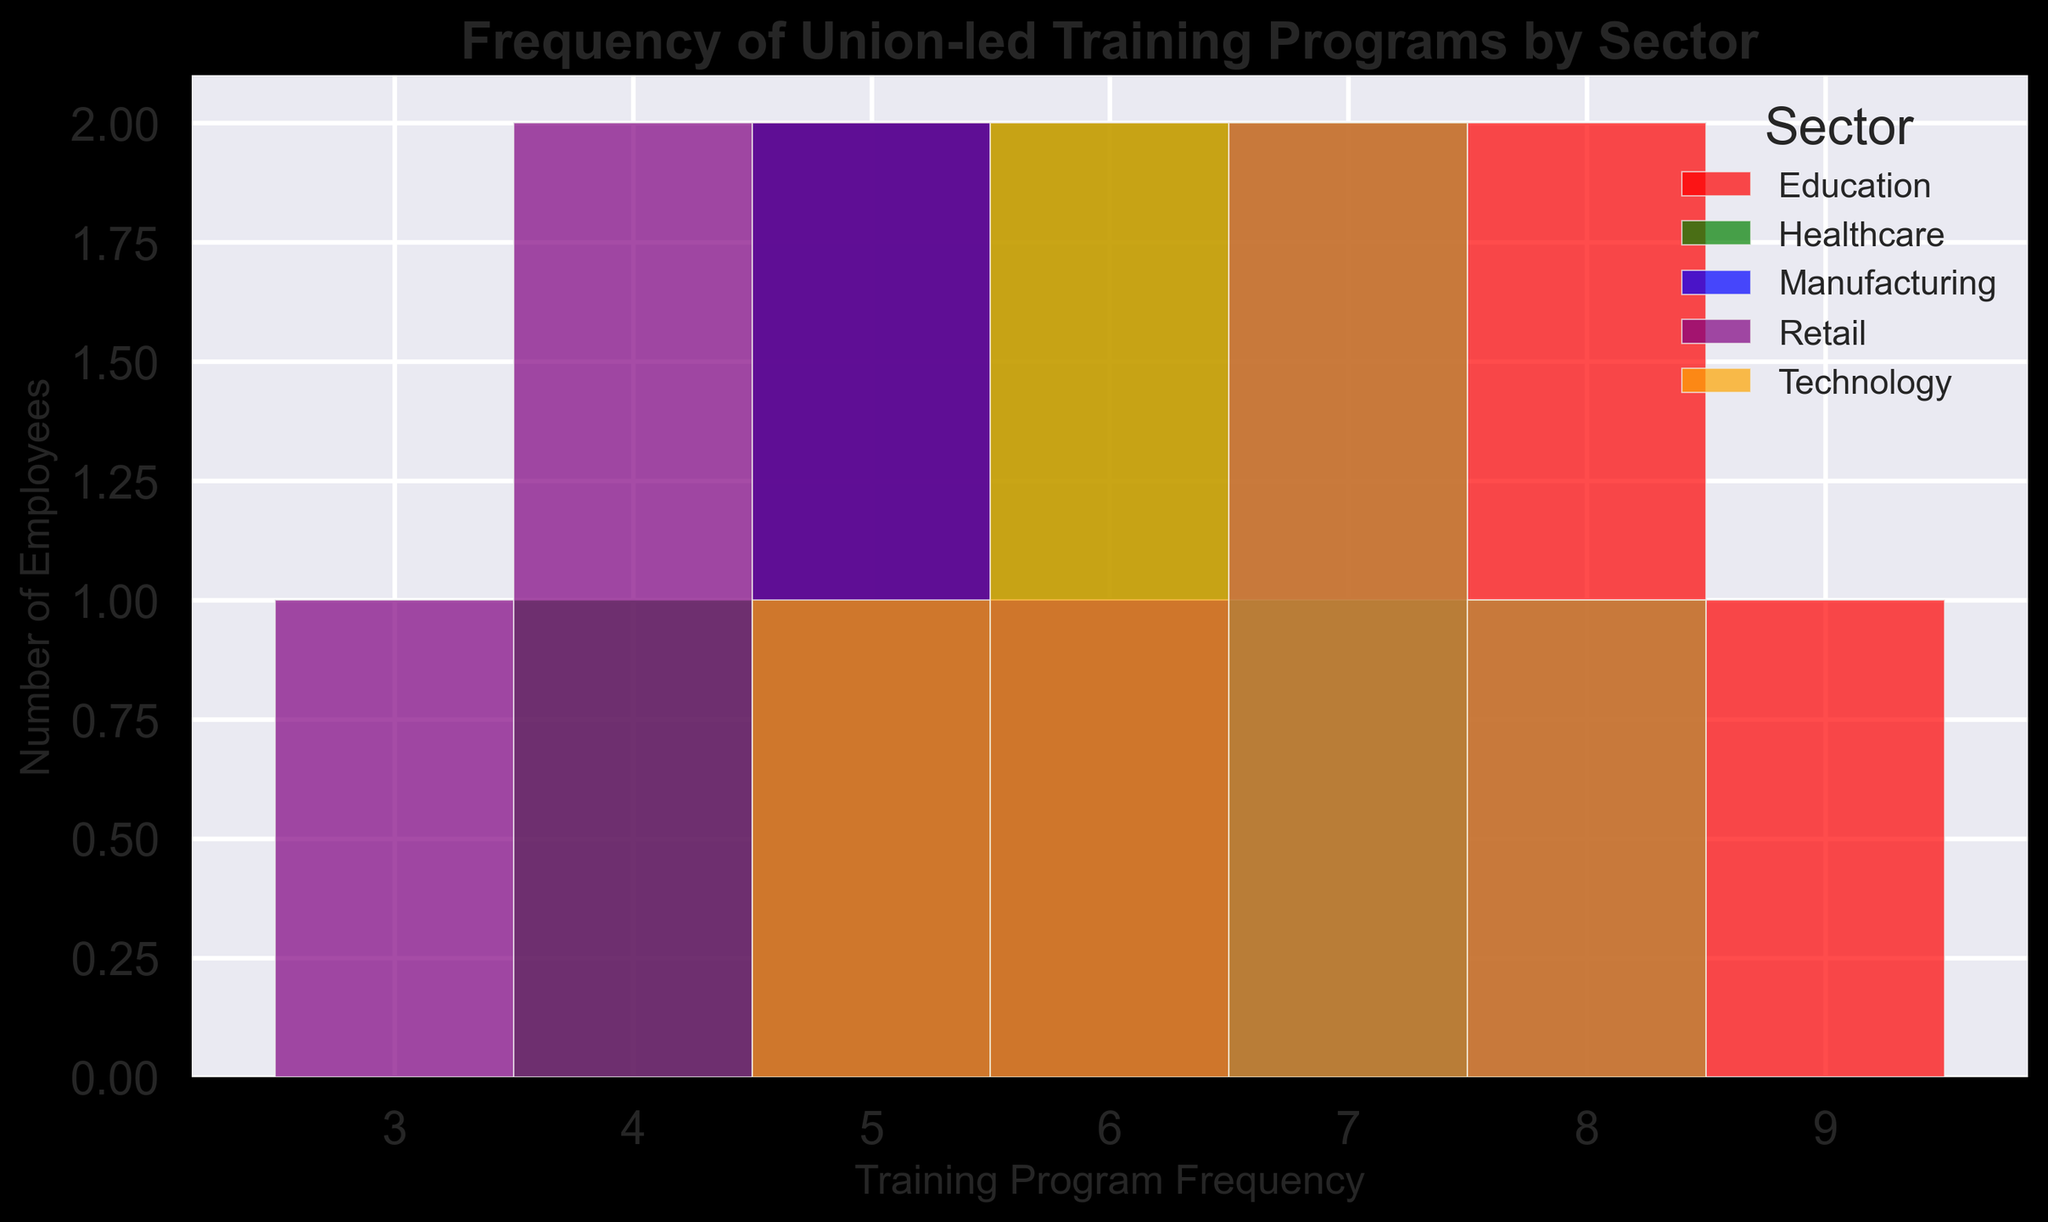Which sector has the highest peak frequency for training programs attended? To determine this, look for the tallest bar in the histogram. The Education sector has the tallest bar at 7 to 9 training programs, indicating the highest peak frequency.
Answer: Education What is the most frequent training program attendance for Retail employees? The histogram shows that for Retail employees, the highest bar appears at 5 training program attendances.
Answer: 5 How do the training program frequencies compare between Manufacturing and Healthcare sectors? Look at the shapes and peak heights of the bars for Manufacturing (blue) and Healthcare (green). Manufacturing has peaks around 5 and 7, while Healthcare has peaks at 5 and 6. Both sectors have different peaks but similar overall height ranges.
Answer: Manufacturing peaks at 5 and 7, Healthcare peaks at 5 and 6 Which sector shows the most diverse range of training program frequencies? Identify the sectors with bars spread over a wide range of frequencies. The Education sector (red) has bars over a wide range from 6 to 9, indicating diverse frequency distribution.
Answer: Education Do any sectors have a similar distribution of training program frequencies? Compare the shapes of the histograms for different sectors. The Healthcare (green) and Manufacturing (blue) sectors have similar peaks at 5 and 6.
Answer: Healthcare and Manufacturing What is the average training program attendance for Manufacturing employees? The frequencies for Manufacturing are 7, 5, 6, 8, 7, and 5. Calculate the average: (7 + 5 + 6 + 8 + 7 + 5) / 6 = 6.333.
Answer: 6.333 How many education employees attended 8 training programs? Locate the bar in the red color (Education) at 8 training programs and read the height. There are two employees.
Answer: 2 Which sector has the lowest attendance in union-led training programs? Look for the sector with bars starting from the lowest frequency values. Retail (purple) has bars beginning as low as 3.
Answer: Retail Does Technology sector show a more concentrated or spread-out attendance compared to Retail? Examine the range and peak of the bars for Technology (orange) vs. Retail (purple). Technology has a concentrated range (5-8) with peaks mainly around 7, whereas Retail has a spread-out, lower range (3-6).
Answer: Technology is more concentrated What is the average training program attendance for the Healthcare sector? The frequencies for Healthcare are 6, 4, 7, 5, 6, and 5. Calculate the average: (6 + 4 + 7 + 5 + 6 + 5) / 6 = 5.5.
Answer: 5.5 